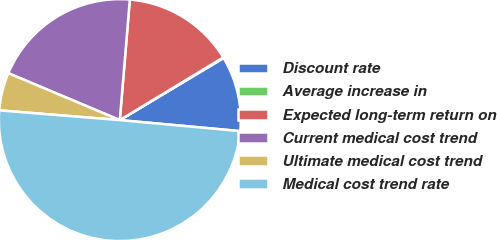<chart> <loc_0><loc_0><loc_500><loc_500><pie_chart><fcel>Discount rate<fcel>Average increase in<fcel>Expected long-term return on<fcel>Current medical cost trend<fcel>Ultimate medical cost trend<fcel>Medical cost trend rate<nl><fcel>10.03%<fcel>0.09%<fcel>15.01%<fcel>19.98%<fcel>5.06%<fcel>49.83%<nl></chart> 